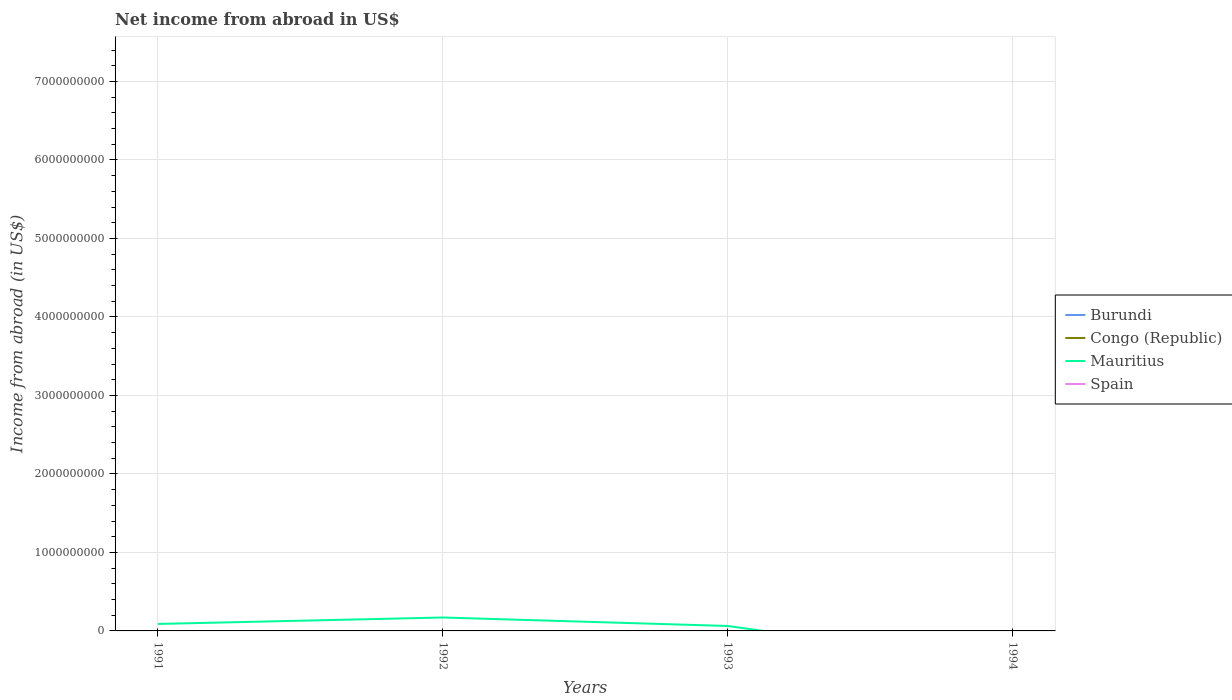What is the difference between the highest and the second highest net income from abroad in Mauritius?
Provide a short and direct response. 1.71e+08. What is the difference between the highest and the lowest net income from abroad in Congo (Republic)?
Your answer should be very brief. 0. What is the difference between two consecutive major ticks on the Y-axis?
Offer a very short reply. 1.00e+09. Does the graph contain grids?
Offer a terse response. Yes. How are the legend labels stacked?
Give a very brief answer. Vertical. What is the title of the graph?
Ensure brevity in your answer.  Net income from abroad in US$. Does "Middle income" appear as one of the legend labels in the graph?
Make the answer very short. No. What is the label or title of the Y-axis?
Provide a succinct answer. Income from abroad (in US$). What is the Income from abroad (in US$) of Burundi in 1991?
Make the answer very short. 0. What is the Income from abroad (in US$) of Congo (Republic) in 1991?
Make the answer very short. 0. What is the Income from abroad (in US$) in Mauritius in 1991?
Your response must be concise. 8.90e+07. What is the Income from abroad (in US$) in Burundi in 1992?
Keep it short and to the point. 0. What is the Income from abroad (in US$) of Mauritius in 1992?
Your response must be concise. 1.71e+08. What is the Income from abroad (in US$) of Spain in 1992?
Your response must be concise. 0. What is the Income from abroad (in US$) in Burundi in 1993?
Give a very brief answer. 0. What is the Income from abroad (in US$) of Congo (Republic) in 1993?
Ensure brevity in your answer.  0. What is the Income from abroad (in US$) of Mauritius in 1993?
Provide a succinct answer. 6.30e+07. What is the Income from abroad (in US$) in Spain in 1993?
Provide a succinct answer. 0. What is the Income from abroad (in US$) in Congo (Republic) in 1994?
Give a very brief answer. 0. What is the Income from abroad (in US$) of Mauritius in 1994?
Ensure brevity in your answer.  0. What is the Income from abroad (in US$) in Spain in 1994?
Your response must be concise. 0. Across all years, what is the maximum Income from abroad (in US$) in Mauritius?
Provide a succinct answer. 1.71e+08. Across all years, what is the minimum Income from abroad (in US$) of Mauritius?
Keep it short and to the point. 0. What is the total Income from abroad (in US$) in Congo (Republic) in the graph?
Your answer should be compact. 0. What is the total Income from abroad (in US$) of Mauritius in the graph?
Give a very brief answer. 3.23e+08. What is the difference between the Income from abroad (in US$) of Mauritius in 1991 and that in 1992?
Your answer should be compact. -8.20e+07. What is the difference between the Income from abroad (in US$) of Mauritius in 1991 and that in 1993?
Offer a very short reply. 2.60e+07. What is the difference between the Income from abroad (in US$) in Mauritius in 1992 and that in 1993?
Your answer should be very brief. 1.08e+08. What is the average Income from abroad (in US$) of Congo (Republic) per year?
Keep it short and to the point. 0. What is the average Income from abroad (in US$) of Mauritius per year?
Offer a very short reply. 8.08e+07. What is the ratio of the Income from abroad (in US$) of Mauritius in 1991 to that in 1992?
Ensure brevity in your answer.  0.52. What is the ratio of the Income from abroad (in US$) of Mauritius in 1991 to that in 1993?
Ensure brevity in your answer.  1.41. What is the ratio of the Income from abroad (in US$) in Mauritius in 1992 to that in 1993?
Offer a very short reply. 2.71. What is the difference between the highest and the second highest Income from abroad (in US$) of Mauritius?
Your answer should be compact. 8.20e+07. What is the difference between the highest and the lowest Income from abroad (in US$) in Mauritius?
Give a very brief answer. 1.71e+08. 